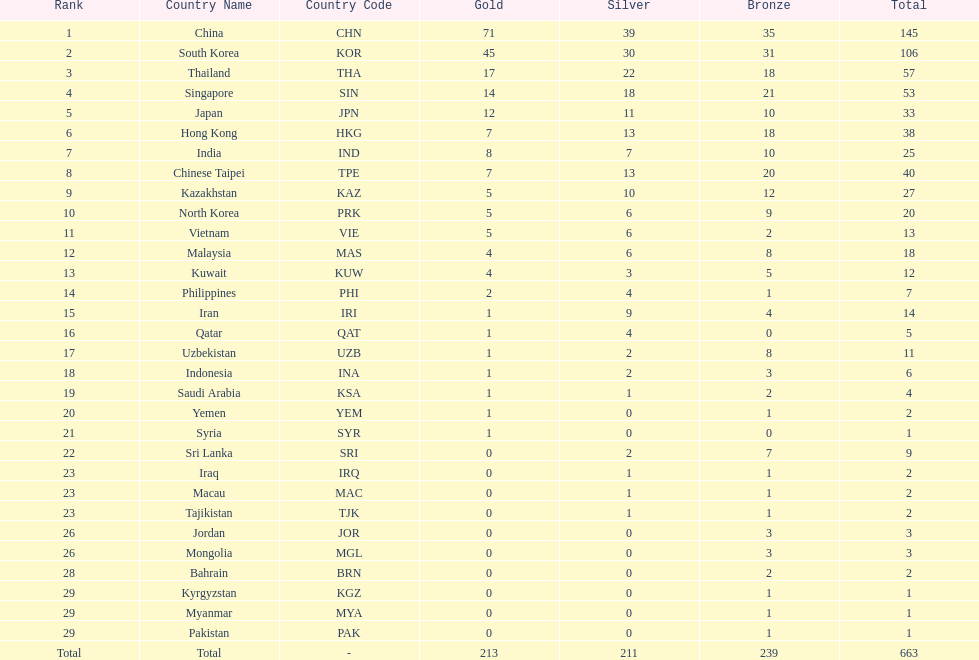What is the difference between the total amount of medals won by qatar and indonesia? 1. 